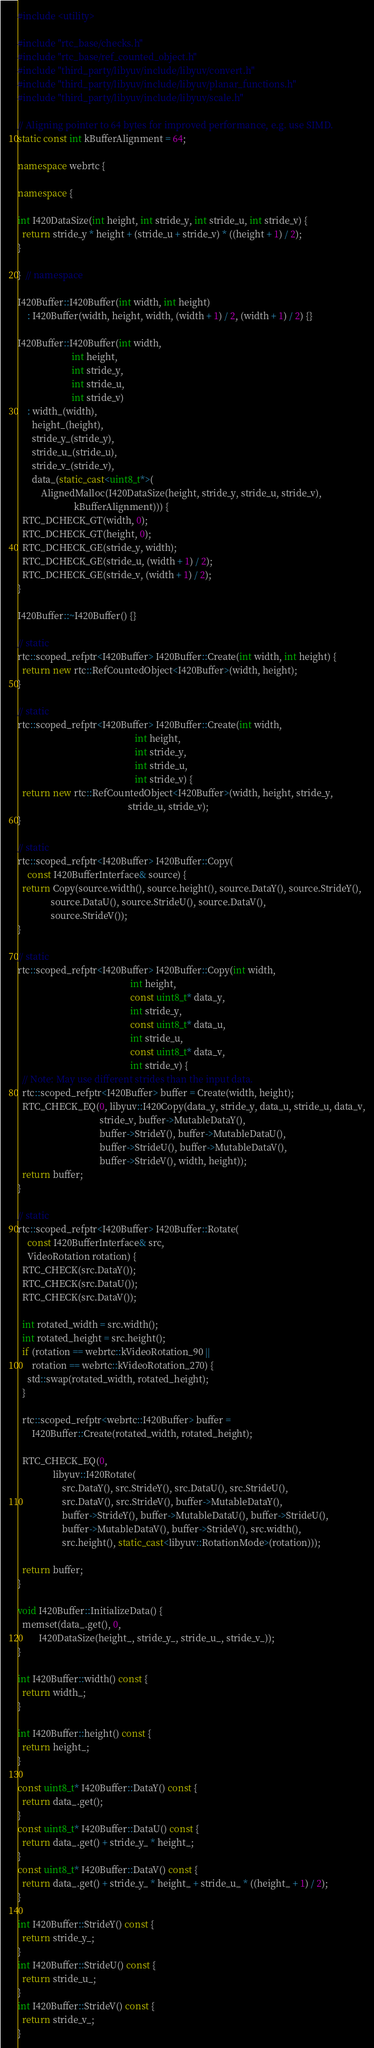Convert code to text. <code><loc_0><loc_0><loc_500><loc_500><_C++_>#include <utility>

#include "rtc_base/checks.h"
#include "rtc_base/ref_counted_object.h"
#include "third_party/libyuv/include/libyuv/convert.h"
#include "third_party/libyuv/include/libyuv/planar_functions.h"
#include "third_party/libyuv/include/libyuv/scale.h"

// Aligning pointer to 64 bytes for improved performance, e.g. use SIMD.
static const int kBufferAlignment = 64;

namespace webrtc {

namespace {

int I420DataSize(int height, int stride_y, int stride_u, int stride_v) {
  return stride_y * height + (stride_u + stride_v) * ((height + 1) / 2);
}

}  // namespace

I420Buffer::I420Buffer(int width, int height)
    : I420Buffer(width, height, width, (width + 1) / 2, (width + 1) / 2) {}

I420Buffer::I420Buffer(int width,
                       int height,
                       int stride_y,
                       int stride_u,
                       int stride_v)
    : width_(width),
      height_(height),
      stride_y_(stride_y),
      stride_u_(stride_u),
      stride_v_(stride_v),
      data_(static_cast<uint8_t*>(
          AlignedMalloc(I420DataSize(height, stride_y, stride_u, stride_v),
                        kBufferAlignment))) {
  RTC_DCHECK_GT(width, 0);
  RTC_DCHECK_GT(height, 0);
  RTC_DCHECK_GE(stride_y, width);
  RTC_DCHECK_GE(stride_u, (width + 1) / 2);
  RTC_DCHECK_GE(stride_v, (width + 1) / 2);
}

I420Buffer::~I420Buffer() {}

// static
rtc::scoped_refptr<I420Buffer> I420Buffer::Create(int width, int height) {
  return new rtc::RefCountedObject<I420Buffer>(width, height);
}

// static
rtc::scoped_refptr<I420Buffer> I420Buffer::Create(int width,
                                                  int height,
                                                  int stride_y,
                                                  int stride_u,
                                                  int stride_v) {
  return new rtc::RefCountedObject<I420Buffer>(width, height, stride_y,
                                               stride_u, stride_v);
}

// static
rtc::scoped_refptr<I420Buffer> I420Buffer::Copy(
    const I420BufferInterface& source) {
  return Copy(source.width(), source.height(), source.DataY(), source.StrideY(),
              source.DataU(), source.StrideU(), source.DataV(),
              source.StrideV());
}

// static
rtc::scoped_refptr<I420Buffer> I420Buffer::Copy(int width,
                                                int height,
                                                const uint8_t* data_y,
                                                int stride_y,
                                                const uint8_t* data_u,
                                                int stride_u,
                                                const uint8_t* data_v,
                                                int stride_v) {
  // Note: May use different strides than the input data.
  rtc::scoped_refptr<I420Buffer> buffer = Create(width, height);
  RTC_CHECK_EQ(0, libyuv::I420Copy(data_y, stride_y, data_u, stride_u, data_v,
                                   stride_v, buffer->MutableDataY(),
                                   buffer->StrideY(), buffer->MutableDataU(),
                                   buffer->StrideU(), buffer->MutableDataV(),
                                   buffer->StrideV(), width, height));
  return buffer;
}

// static
rtc::scoped_refptr<I420Buffer> I420Buffer::Rotate(
    const I420BufferInterface& src,
    VideoRotation rotation) {
  RTC_CHECK(src.DataY());
  RTC_CHECK(src.DataU());
  RTC_CHECK(src.DataV());

  int rotated_width = src.width();
  int rotated_height = src.height();
  if (rotation == webrtc::kVideoRotation_90 ||
      rotation == webrtc::kVideoRotation_270) {
    std::swap(rotated_width, rotated_height);
  }

  rtc::scoped_refptr<webrtc::I420Buffer> buffer =
      I420Buffer::Create(rotated_width, rotated_height);

  RTC_CHECK_EQ(0,
               libyuv::I420Rotate(
                   src.DataY(), src.StrideY(), src.DataU(), src.StrideU(),
                   src.DataV(), src.StrideV(), buffer->MutableDataY(),
                   buffer->StrideY(), buffer->MutableDataU(), buffer->StrideU(),
                   buffer->MutableDataV(), buffer->StrideV(), src.width(),
                   src.height(), static_cast<libyuv::RotationMode>(rotation)));

  return buffer;
}

void I420Buffer::InitializeData() {
  memset(data_.get(), 0,
         I420DataSize(height_, stride_y_, stride_u_, stride_v_));
}

int I420Buffer::width() const {
  return width_;
}

int I420Buffer::height() const {
  return height_;
}

const uint8_t* I420Buffer::DataY() const {
  return data_.get();
}
const uint8_t* I420Buffer::DataU() const {
  return data_.get() + stride_y_ * height_;
}
const uint8_t* I420Buffer::DataV() const {
  return data_.get() + stride_y_ * height_ + stride_u_ * ((height_ + 1) / 2);
}

int I420Buffer::StrideY() const {
  return stride_y_;
}
int I420Buffer::StrideU() const {
  return stride_u_;
}
int I420Buffer::StrideV() const {
  return stride_v_;
}
</code> 